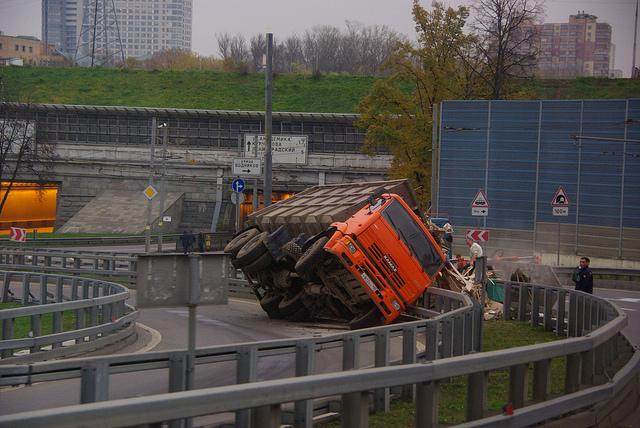Which speed during the turn caused this to happen?

Choices:
A) stopping
B) decelerating
C) high
D) low high 